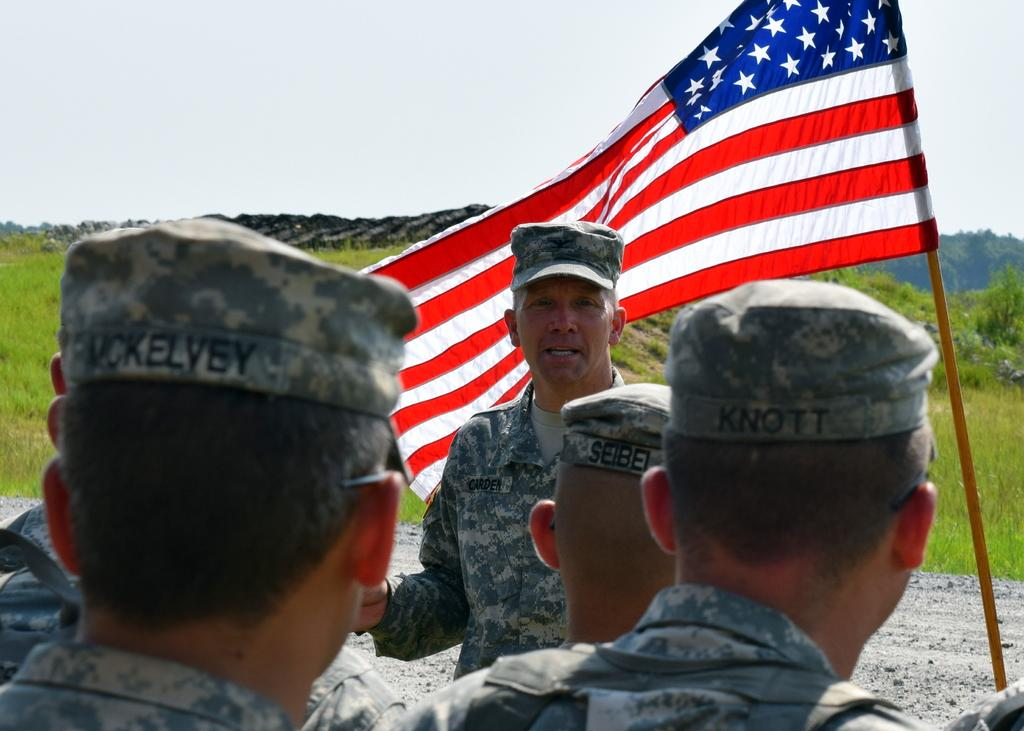What are the people in the image doing? The people in the image are standing on the road. What can be seen on the right side of the image? There is a flag on the right side of the image. What is visible in the background of the image? There are mountains and the sky visible in the background of the image. What type of polish is being applied to the button in the image? There is no button or polish present in the image. How does the lock on the door in the image work? There is no door or lock present in the image. 